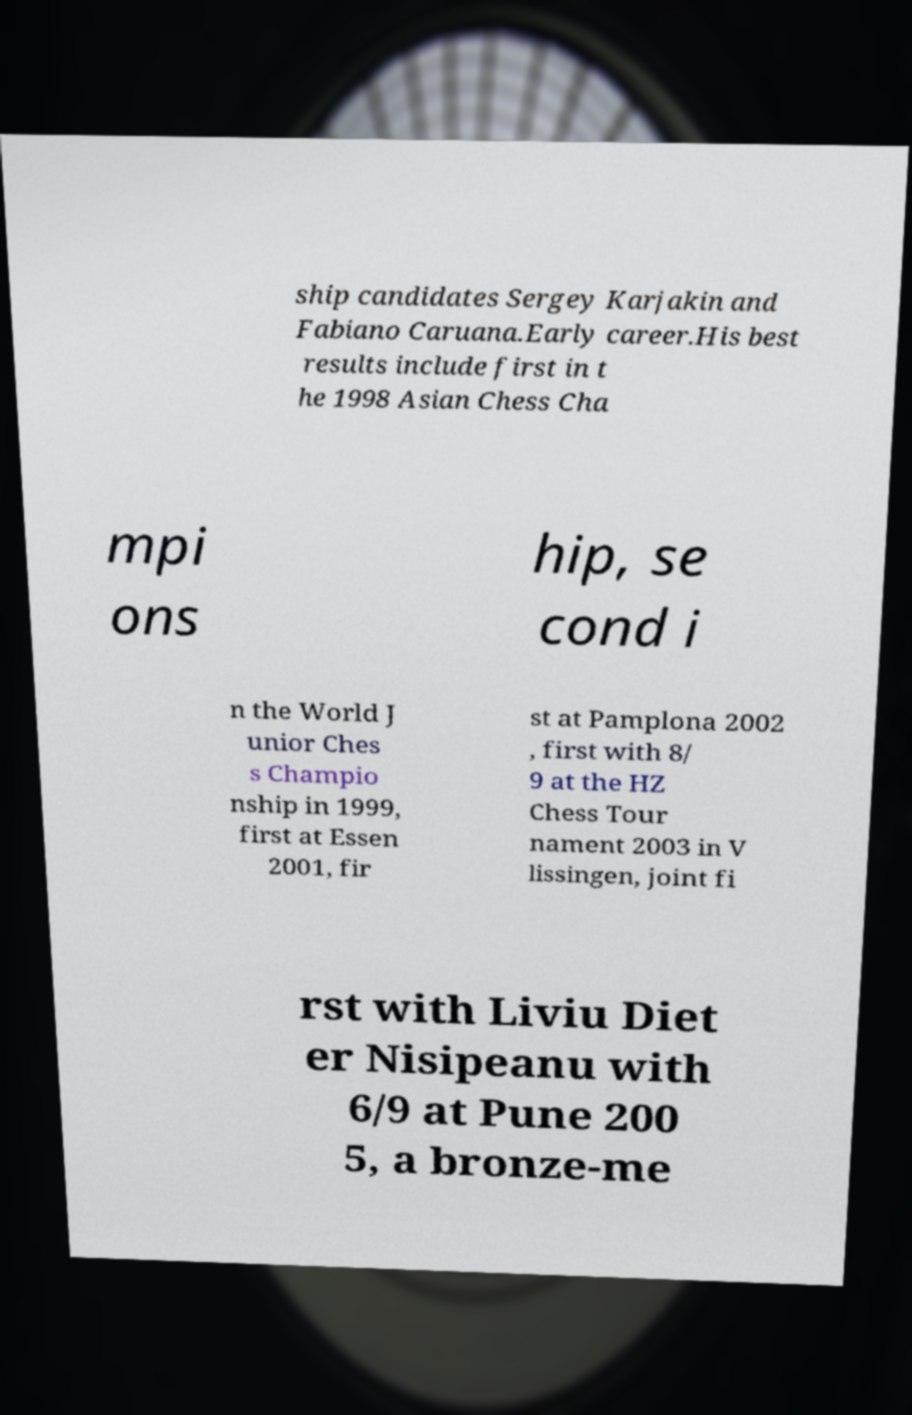For documentation purposes, I need the text within this image transcribed. Could you provide that? ship candidates Sergey Karjakin and Fabiano Caruana.Early career.His best results include first in t he 1998 Asian Chess Cha mpi ons hip, se cond i n the World J unior Ches s Champio nship in 1999, first at Essen 2001, fir st at Pamplona 2002 , first with 8/ 9 at the HZ Chess Tour nament 2003 in V lissingen, joint fi rst with Liviu Diet er Nisipeanu with 6/9 at Pune 200 5, a bronze-me 